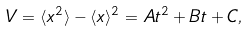<formula> <loc_0><loc_0><loc_500><loc_500>V = \langle x ^ { 2 } \rangle - \langle x \rangle ^ { 2 } = A t ^ { 2 } + B t + C ,</formula> 